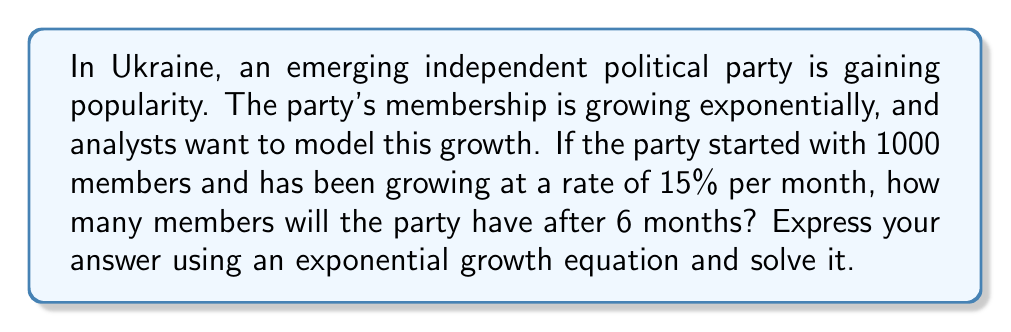Could you help me with this problem? To solve this problem, we'll use the exponential growth equation:

$$A(t) = A_0 e^{rt}$$

Where:
$A(t)$ is the amount at time $t$
$A_0$ is the initial amount
$r$ is the growth rate
$t$ is the time

Given:
$A_0 = 1000$ (initial members)
$r = 0.15$ (15% growth rate per month)
$t = 6$ (months)

Let's plug these values into our equation:

$$A(6) = 1000 \cdot e^{0.15 \cdot 6}$$

Now, let's solve this step-by-step:

1) First, simplify the exponent:
   $$A(6) = 1000 \cdot e^{0.9}$$

2) Calculate $e^{0.9}$ (you can use a calculator for this):
   $$e^{0.9} \approx 2.4596$$

3) Multiply by 1000:
   $$A(6) = 1000 \cdot 2.4596 \approx 2459.6$$

4) Round to the nearest whole number, as we can't have partial members:
   $$A(6) \approx 2460$$

Therefore, after 6 months, the independent political party will have approximately 2460 members.
Answer: $A(6) = 1000 \cdot e^{0.15 \cdot 6} \approx 2460$ members 